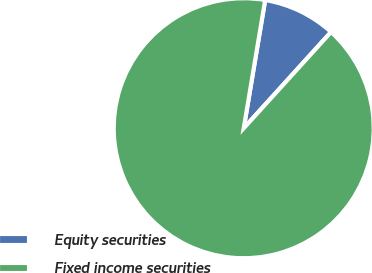Convert chart to OTSL. <chart><loc_0><loc_0><loc_500><loc_500><pie_chart><fcel>Equity securities<fcel>Fixed income securities<nl><fcel>9.09%<fcel>90.91%<nl></chart> 